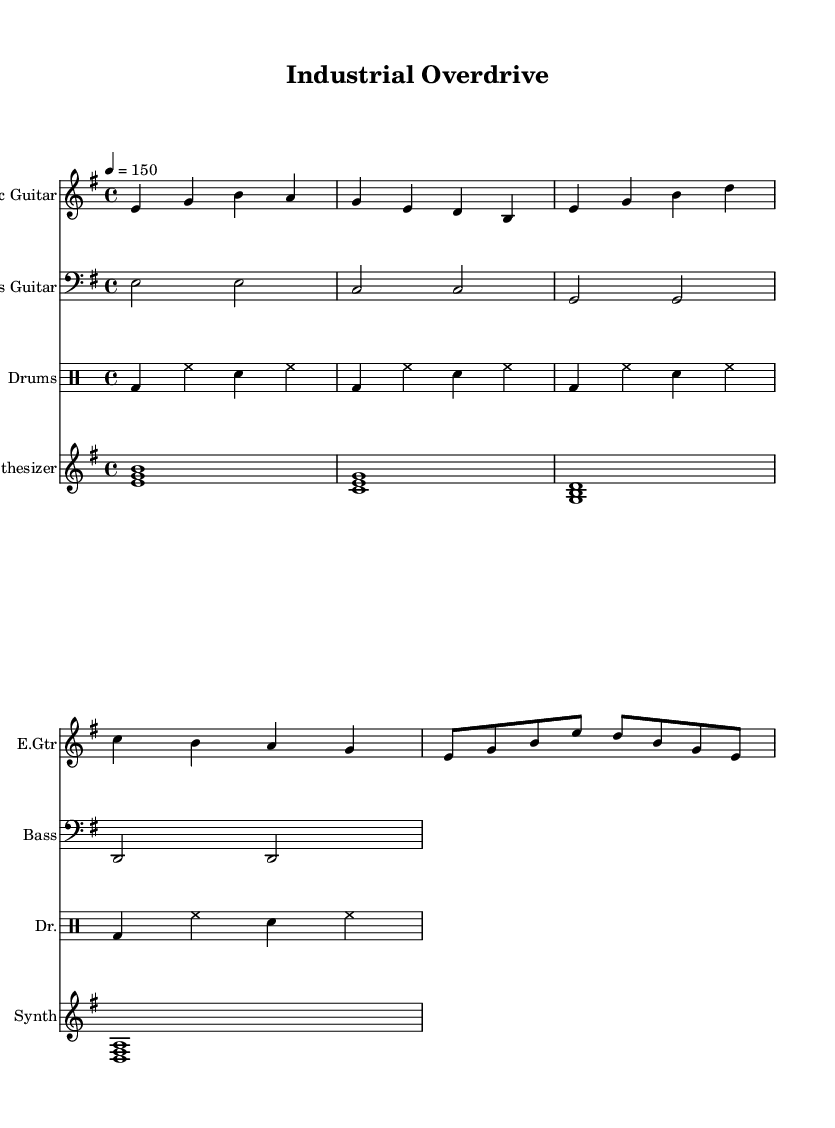What is the key signature of this music? The key signature indicated in the music is E minor, which contains one sharp (F#).
Answer: E minor What is the time signature of this music? The time signature is shown as 4/4, meaning there are four beats in each measure and the quarter note gets one beat.
Answer: 4/4 What is the tempo marking for this piece? The tempo marking indicates a speed of 150 beats per minute, indicated by the symbol "4 = 150".
Answer: 150 Which instrument plays the main melody in this piece? The main melody is played by the electric guitar, as indicated by the instrument name at the top of the staff.
Answer: Electric Guitar How many measures are in the section for the electric guitar? The electric guitar section consists of eight measures, which can be counted based on the notation presented.
Answer: Eight Which clef is used for the bass guitar part? The bass guitar staff uses the bass clef, which is indicated by the clef symbol at the beginning of the staff.
Answer: Bass clef What type of music is this piece categorized under? This piece can be categorized as energetic rock instrumentals suitable for high-pressure situations, as inferred from the title and the instrumentation.
Answer: Energetic rock instrumentals 